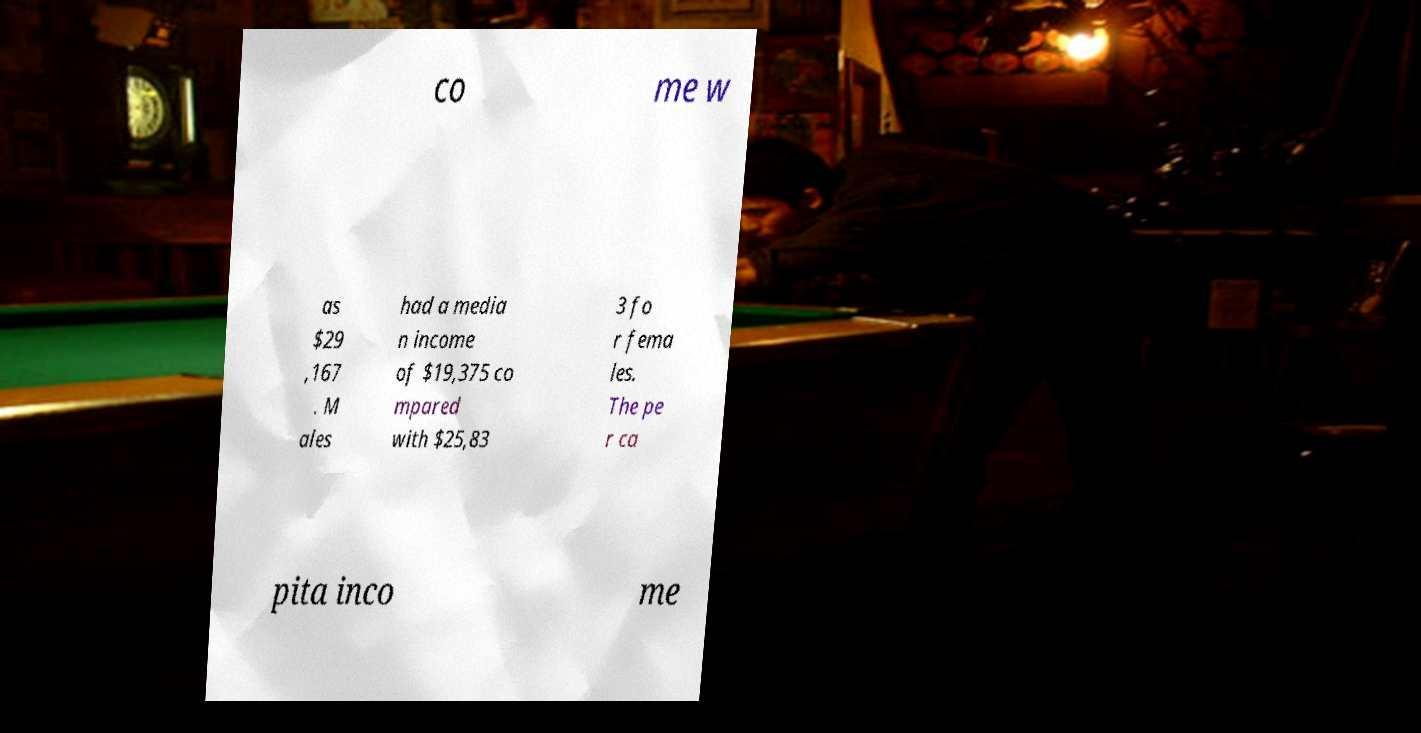Please identify and transcribe the text found in this image. co me w as $29 ,167 . M ales had a media n income of $19,375 co mpared with $25,83 3 fo r fema les. The pe r ca pita inco me 